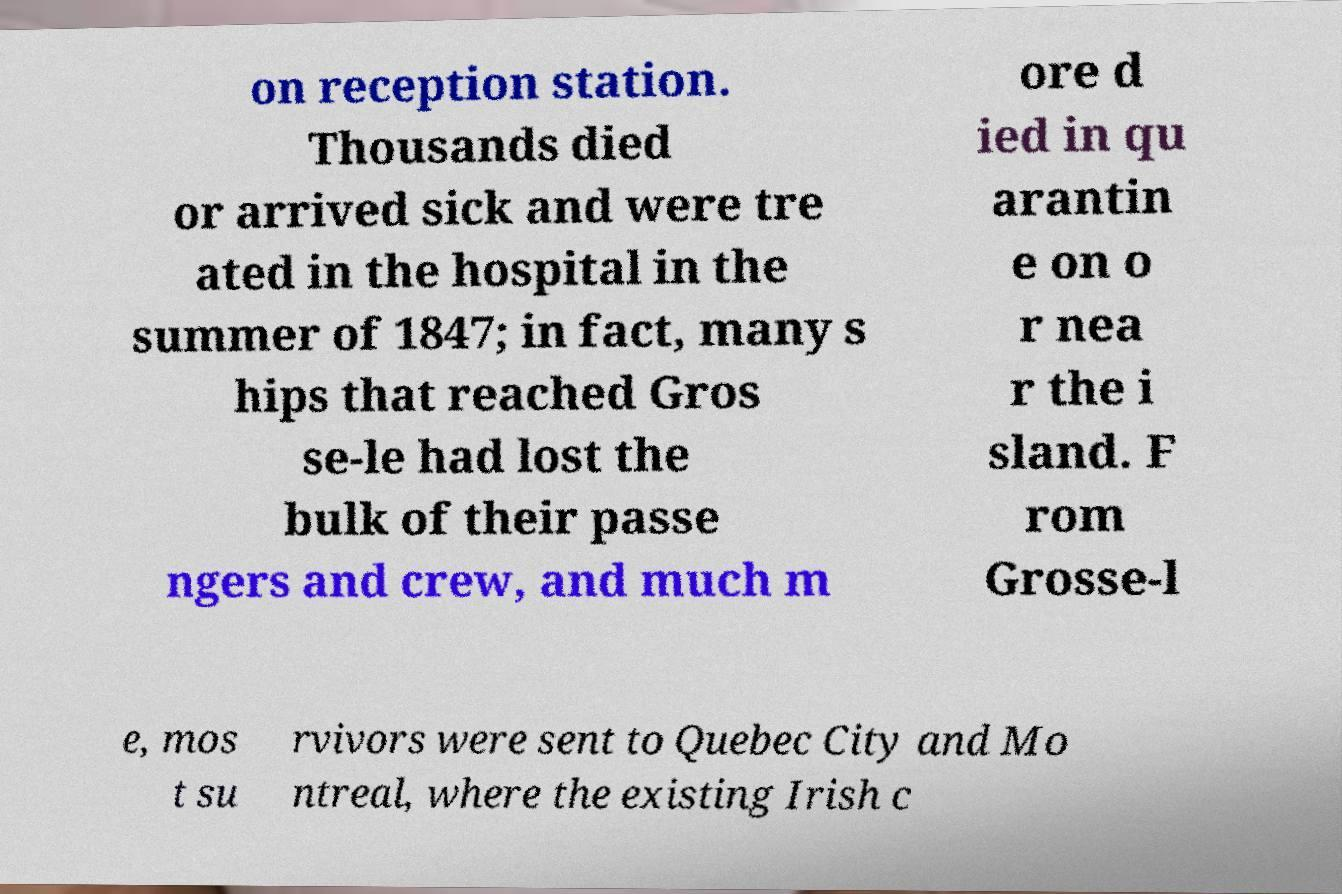Could you assist in decoding the text presented in this image and type it out clearly? on reception station. Thousands died or arrived sick and were tre ated in the hospital in the summer of 1847; in fact, many s hips that reached Gros se-le had lost the bulk of their passe ngers and crew, and much m ore d ied in qu arantin e on o r nea r the i sland. F rom Grosse-l e, mos t su rvivors were sent to Quebec City and Mo ntreal, where the existing Irish c 